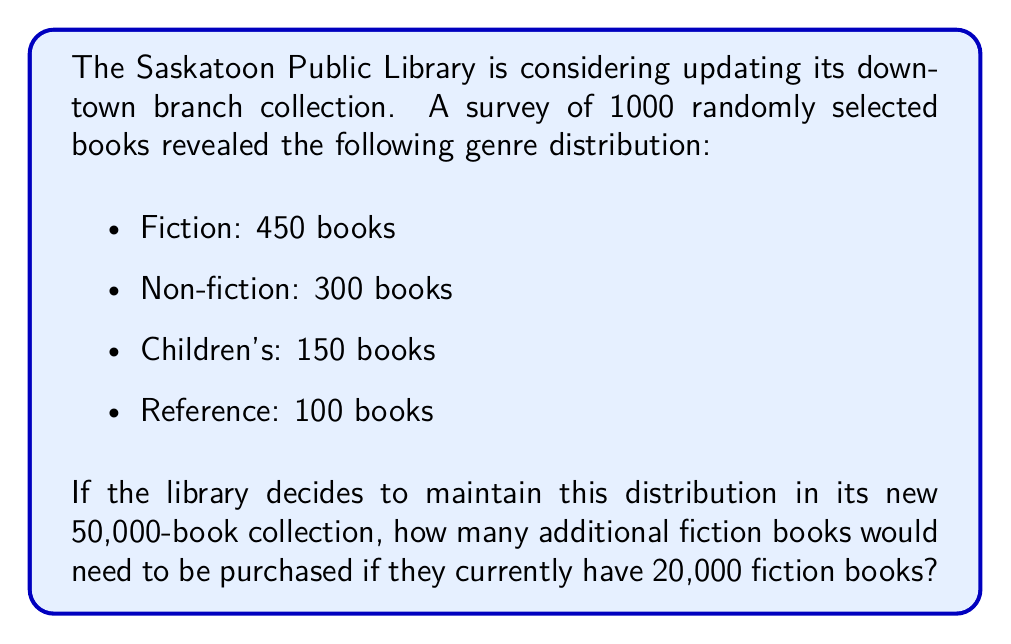Provide a solution to this math problem. To solve this problem, we need to follow these steps:

1. Calculate the proportion of fiction books in the sample:
   $$\text{Fiction proportion} = \frac{450}{1000} = 0.45 = 45\%$$

2. Determine the number of fiction books needed in the new collection:
   $$\text{Fiction books needed} = 50,000 \times 0.45 = 22,500$$

3. Calculate the difference between the needed and current fiction books:
   $$\text{Additional books needed} = 22,500 - 20,000 = 2,500$$

This calculation shows that to maintain the same proportion of fiction books in the new, larger collection, the library would need to purchase 2,500 additional fiction books.

This problem is relevant to the Saskatoon resident persona as it demonstrates how the library's collection would grow and change with the new downtown branch, potentially affecting the value proposition of the new library for local residents.
Answer: 2,500 additional fiction books 